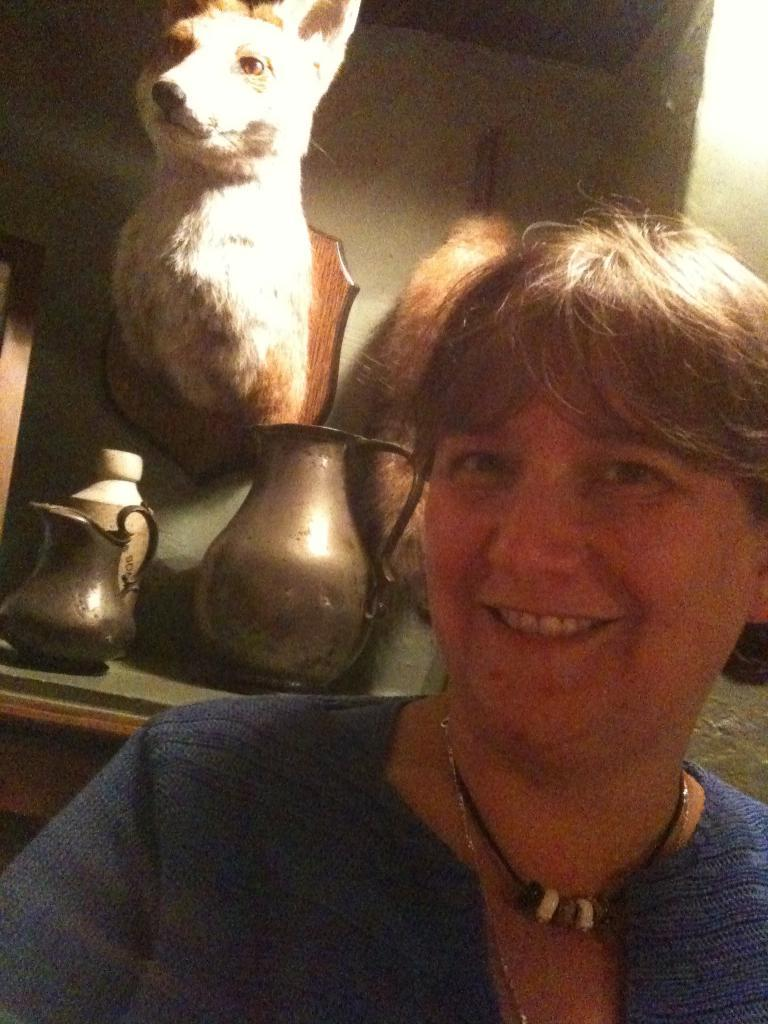What is the animal-like structure attached to the wall in the image? There is an animal-like structure attached to the wall at the top of the image. What objects can be seen on the table in the image? Jugs are placed on a table in the image. Can you describe the woman at the bottom of the image? There is a woman at the bottom of the image. How many seats are available for the woman to sit on in the image? There is no mention of seats in the image, so it is impossible to determine how many seats are available for the woman to sit on. 